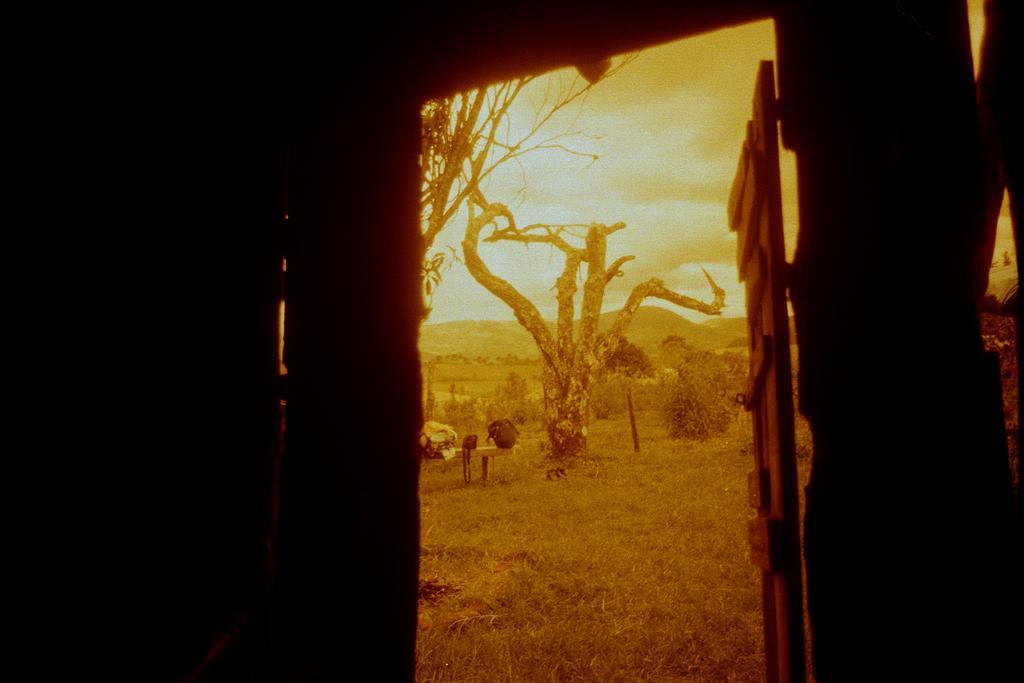Please provide a concise description of this image. In the picture we can see from a dark house outside, we can see a grass surface and on it we can see a dried tree, and beside it, we can see a bench and on it we can see some bags and behind it we can see some trees, hills and sky with clouds. 